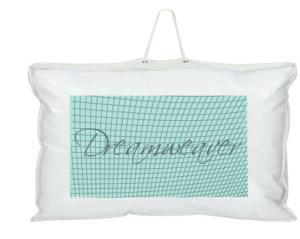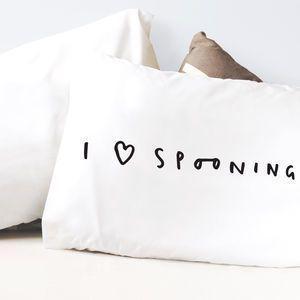The first image is the image on the left, the second image is the image on the right. For the images displayed, is the sentence "The left and right image contains the same number of white pillows" factually correct? Answer yes or no. No. The first image is the image on the left, the second image is the image on the right. Assess this claim about the two images: "The left image contains a handled pillow shape with black text printed on its front, and the right image features a pillow with no handle.". Correct or not? Answer yes or no. Yes. 